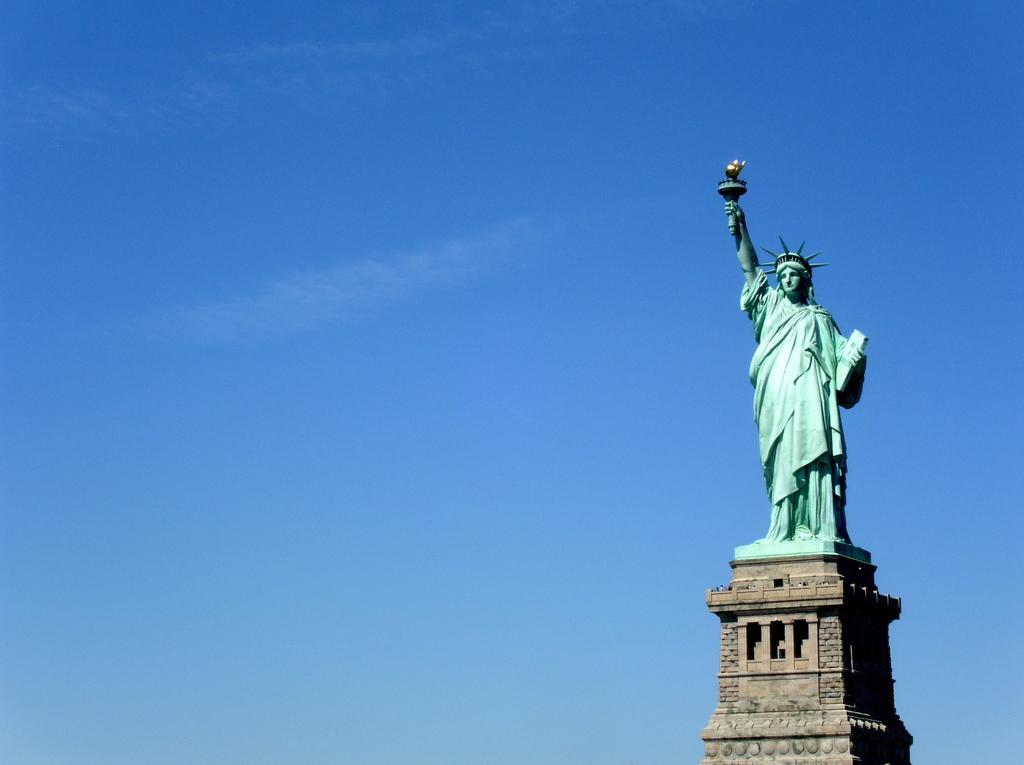How would you summarize this image in a sentence or two? This image is taken outdoors. In the background there is a sky with clouds. On the right side of the image there is a statue of liberty on the tower. 